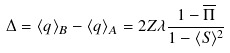<formula> <loc_0><loc_0><loc_500><loc_500>\Delta = \langle q \rangle _ { B } - \langle q \rangle _ { A } = 2 Z \lambda \frac { 1 - \overline { \Pi } } { 1 - \langle S \rangle ^ { 2 } }</formula> 